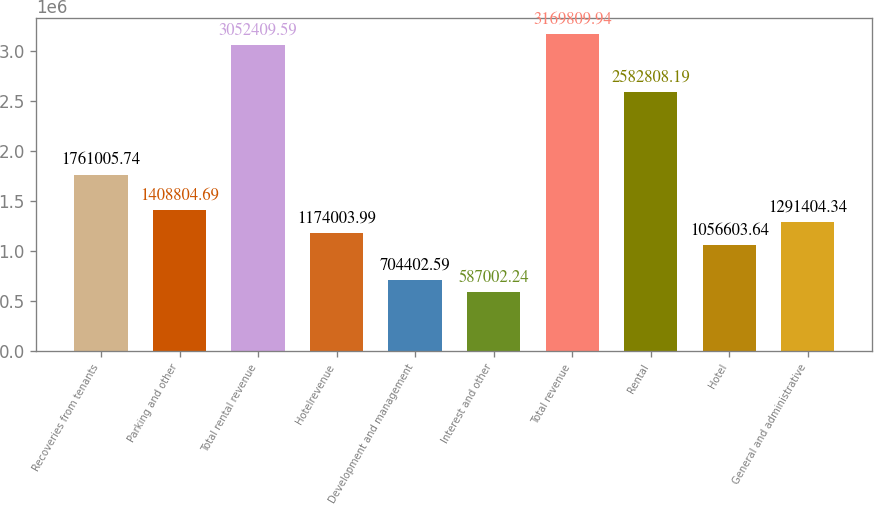<chart> <loc_0><loc_0><loc_500><loc_500><bar_chart><fcel>Recoveries from tenants<fcel>Parking and other<fcel>Total rental revenue<fcel>Hotelrevenue<fcel>Development and management<fcel>Interest and other<fcel>Total revenue<fcel>Rental<fcel>Hotel<fcel>General and administrative<nl><fcel>1.76101e+06<fcel>1.4088e+06<fcel>3.05241e+06<fcel>1.174e+06<fcel>704403<fcel>587002<fcel>3.16981e+06<fcel>2.58281e+06<fcel>1.0566e+06<fcel>1.2914e+06<nl></chart> 